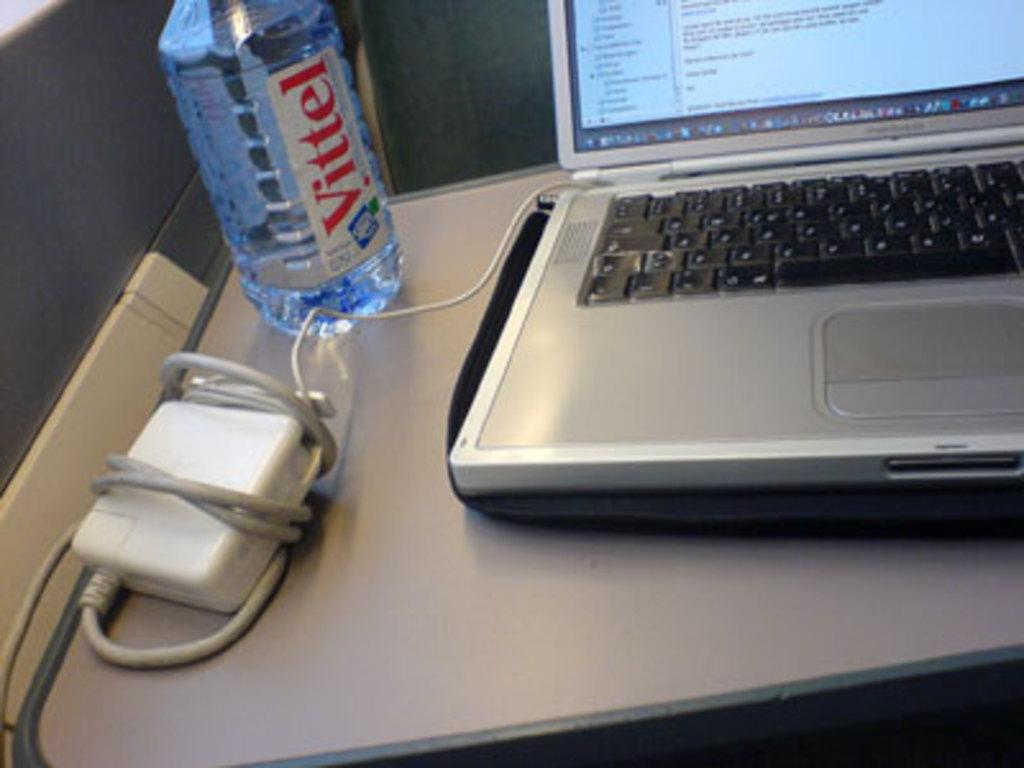What electronic device is visible in the image? There is a laptop in the image. What is the purpose of the socket in the image? The socket is likely for plugging in electrical devices, such as the laptop. What can be seen beside the laptop and socket? There is a water bottle in the image. Where are all these objects located? All of these objects are on a table. What does the laptop need to do in order to hear the voice in the image? There is no voice present in the image, so the laptop does not need to do anything to hear it. 